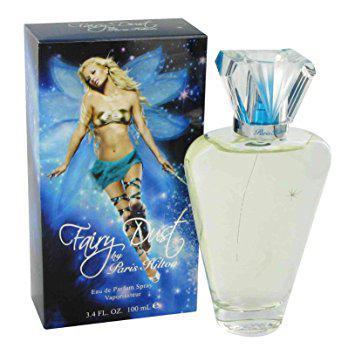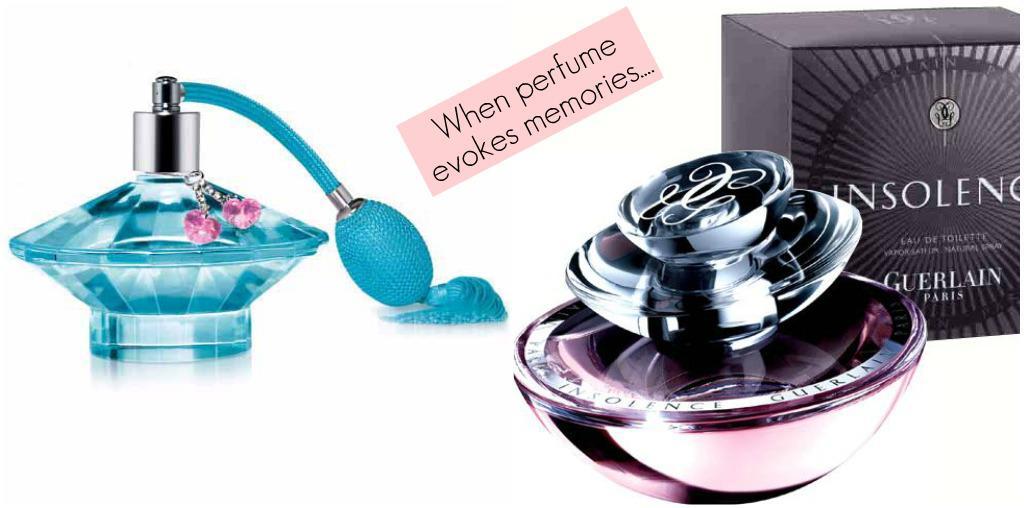The first image is the image on the left, the second image is the image on the right. Given the left and right images, does the statement "In one of the images, there is a single bottle of perfume and it is pink." hold true? Answer yes or no. No. The first image is the image on the left, the second image is the image on the right. Examine the images to the left and right. Is the description "One image includes a single perfume bottle, which has a pink non-square top." accurate? Answer yes or no. No. 